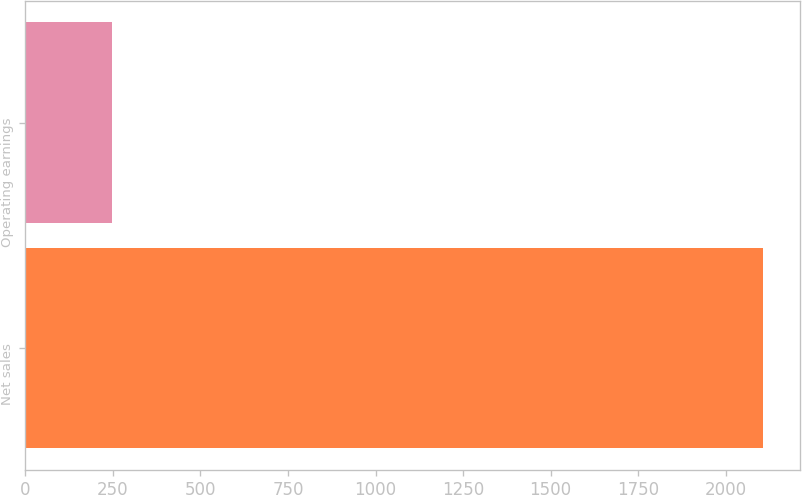Convert chart to OTSL. <chart><loc_0><loc_0><loc_500><loc_500><bar_chart><fcel>Net sales<fcel>Operating earnings<nl><fcel>2107<fcel>248<nl></chart> 